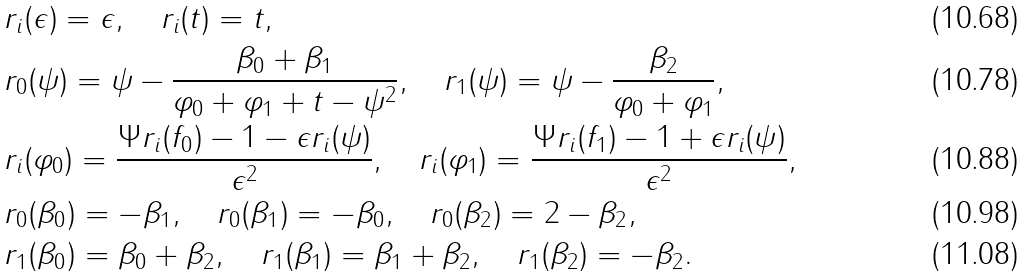<formula> <loc_0><loc_0><loc_500><loc_500>& r _ { i } ( \epsilon ) = \epsilon , \quad r _ { i } ( t ) = t , \\ & r _ { 0 } ( \psi ) = \psi - \frac { \beta _ { 0 } + \beta _ { 1 } } { \varphi _ { 0 } + \varphi _ { 1 } + t - \psi ^ { 2 } } , \quad r _ { 1 } ( \psi ) = \psi - \frac { \beta _ { 2 } } { \varphi _ { 0 } + \varphi _ { 1 } } , \\ & r _ { i } ( \varphi _ { 0 } ) = \frac { \Psi r _ { i } ( f _ { 0 } ) - 1 - \epsilon r _ { i } ( \psi ) } { \epsilon ^ { 2 } } , \quad r _ { i } ( \varphi _ { 1 } ) = \frac { \Psi r _ { i } ( f _ { 1 } ) - 1 + \epsilon r _ { i } ( \psi ) } { \epsilon ^ { 2 } } , \\ & r _ { 0 } ( \beta _ { 0 } ) = - \beta _ { 1 } , \quad r _ { 0 } ( \beta _ { 1 } ) = - \beta _ { 0 } , \quad r _ { 0 } ( \beta _ { 2 } ) = 2 - \beta _ { 2 } , \\ & r _ { 1 } ( \beta _ { 0 } ) = \beta _ { 0 } + \beta _ { 2 } , \quad r _ { 1 } ( \beta _ { 1 } ) = \beta _ { 1 } + \beta _ { 2 } , \quad r _ { 1 } ( \beta _ { 2 } ) = - \beta _ { 2 } .</formula> 